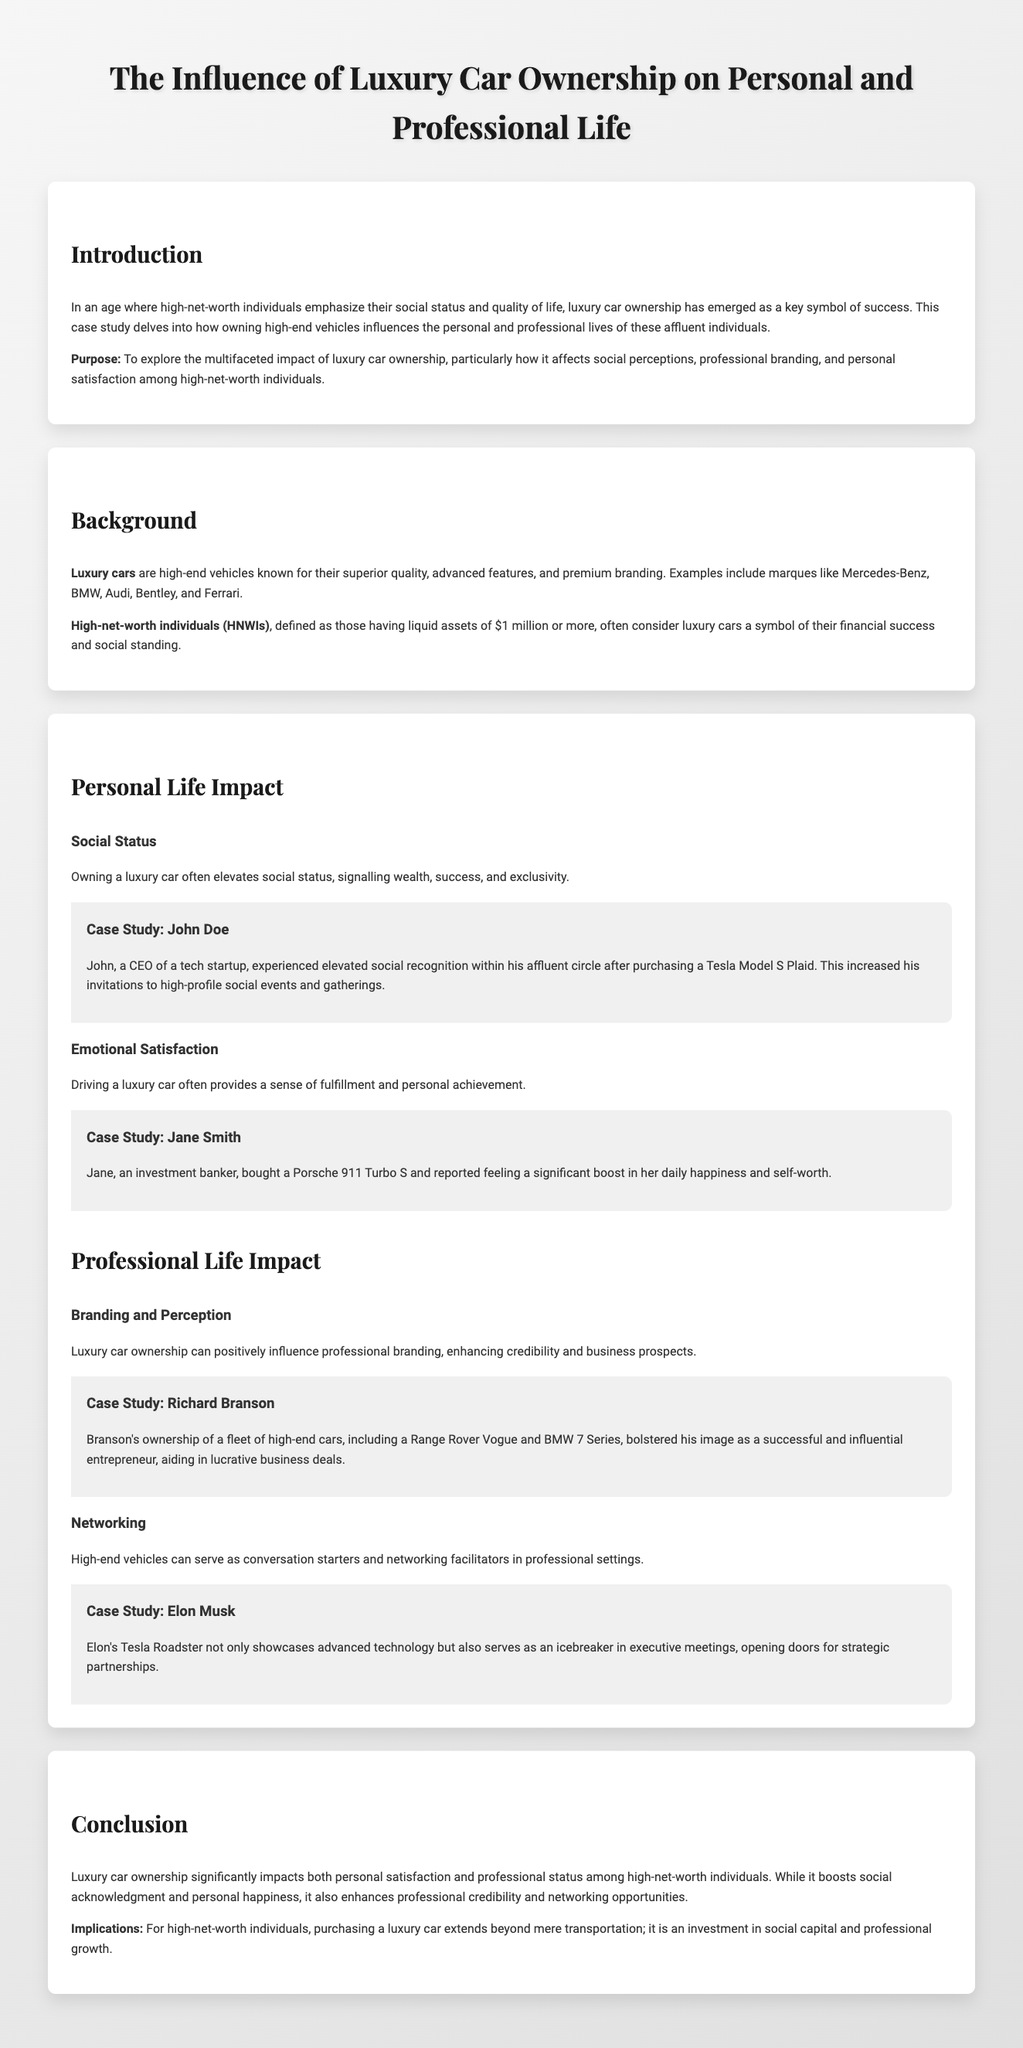What is the main focus of the case study? The case study explores how luxury car ownership influences personal and professional lives of high-net-worth individuals.
Answer: The influence of luxury car ownership Who is the author of the luxury car case study? The document does not specify an author.
Answer: Not specified What is the definition of high-net-worth individuals (HNWIs)? HNWIs are defined as those having liquid assets of $1 million or more.
Answer: $1 million Which luxury car did John Doe purchase? John Doe purchased a Tesla Model S Plaid, which is mentioned in his case study.
Answer: Tesla Model S Plaid What personal benefit did Jane Smith report after buying a luxury car? Jane Smith reported feeling a significant boost in her daily happiness and self-worth after purchasing a Porsche 911 Turbo S.
Answer: Boost in happiness and self-worth How did Richard Branson's luxury car ownership influence his professional image? Richard Branson's ownership of high-end cars bolstered his image as a successful and influential entrepreneur.
Answer: Successful and influential image What type of vehicle does Elon Musk own that serves as an icebreaker? Elon Musk owns a Tesla Roadster, which serves as an icebreaker in meetings.
Answer: Tesla Roadster What is one implication of luxury car ownership mentioned in the conclusion? One implication is that purchasing a luxury car is an investment in social capital and professional growth.
Answer: Investment in social capital What enhances professional credibility according to the document? Luxury car ownership can positively influence professional branding, enhancing credibility.
Answer: Luxury car ownership 